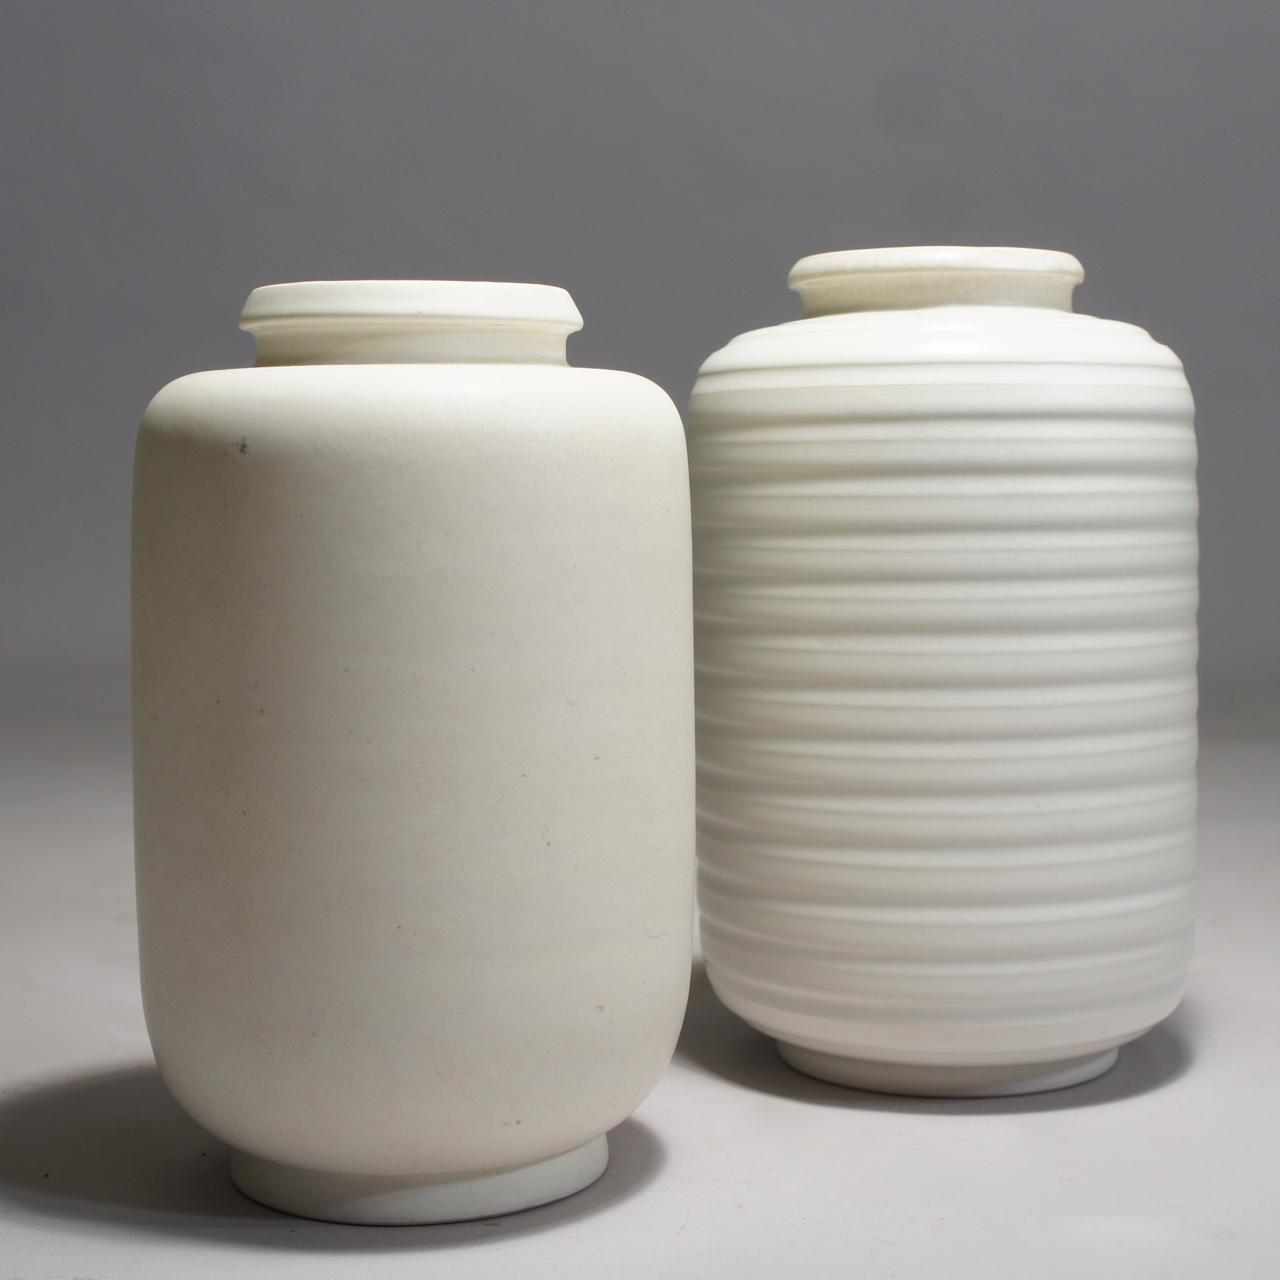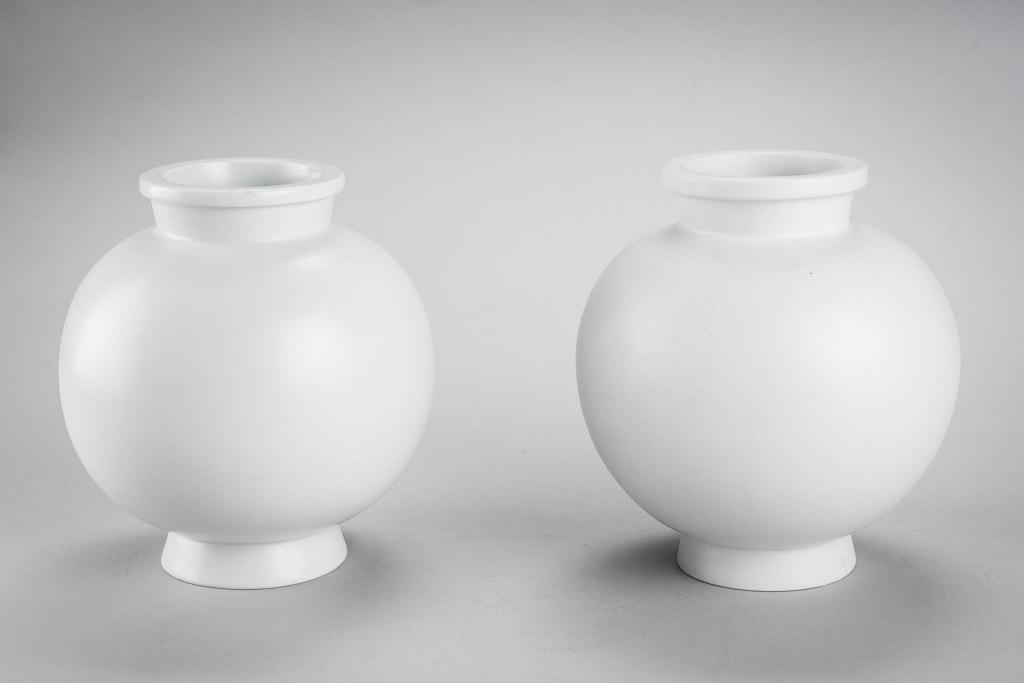The first image is the image on the left, the second image is the image on the right. For the images shown, is this caption "There are four pieces of pottery with four holes." true? Answer yes or no. Yes. The first image is the image on the left, the second image is the image on the right. For the images displayed, is the sentence "There are four white vases standing in groups of two." factually correct? Answer yes or no. Yes. 